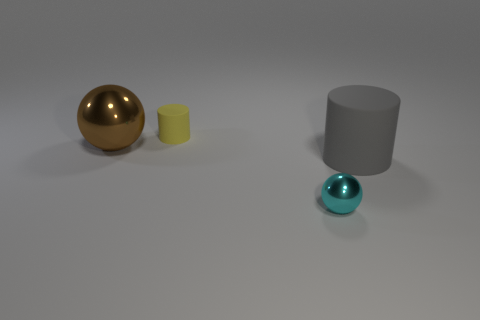Is the number of big purple matte balls greater than the number of gray cylinders?
Offer a terse response. No. What number of objects are both to the left of the tiny cyan object and to the right of the large ball?
Ensure brevity in your answer.  1. What is the shape of the shiny object on the left side of the ball that is in front of the rubber thing that is on the right side of the yellow cylinder?
Your answer should be compact. Sphere. How many cubes are either big yellow metallic objects or large things?
Give a very brief answer. 0. There is a matte thing that is on the left side of the tiny metallic sphere; is it the same color as the large sphere?
Your answer should be very brief. No. What material is the ball to the right of the tiny thing that is behind the shiny ball behind the large cylinder?
Keep it short and to the point. Metal. Does the brown metallic thing have the same size as the gray matte cylinder?
Offer a very short reply. Yes. Does the large rubber thing have the same color as the sphere that is to the left of the yellow cylinder?
Ensure brevity in your answer.  No. There is another object that is made of the same material as the cyan thing; what is its shape?
Provide a succinct answer. Sphere. There is a metallic thing right of the brown metal object; is its shape the same as the gray rubber object?
Offer a very short reply. No. 